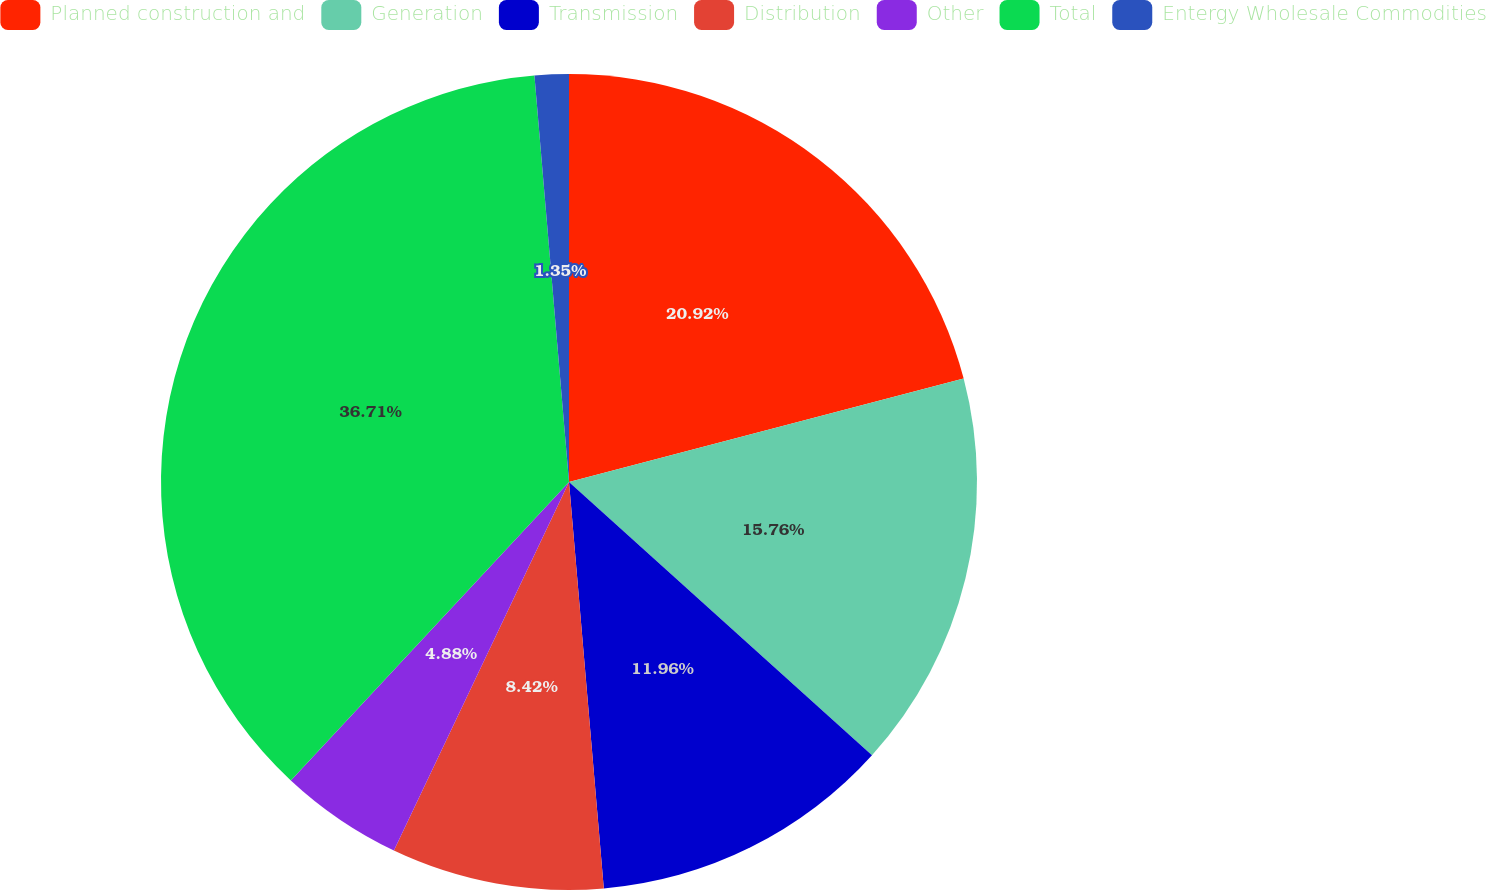Convert chart. <chart><loc_0><loc_0><loc_500><loc_500><pie_chart><fcel>Planned construction and<fcel>Generation<fcel>Transmission<fcel>Distribution<fcel>Other<fcel>Total<fcel>Entergy Wholesale Commodities<nl><fcel>20.92%<fcel>15.76%<fcel>11.96%<fcel>8.42%<fcel>4.88%<fcel>36.71%<fcel>1.35%<nl></chart> 